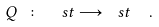<formula> <loc_0><loc_0><loc_500><loc_500>Q \ \colon \ \ s t \longrightarrow \ s t \ \ .</formula> 